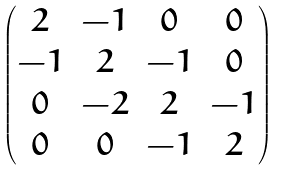<formula> <loc_0><loc_0><loc_500><loc_500>\begin{pmatrix} 2 & - 1 & 0 & 0 \\ - 1 & 2 & - 1 & 0 \\ 0 & - 2 & 2 & - 1 \\ 0 & 0 & - 1 & 2 \end{pmatrix}</formula> 